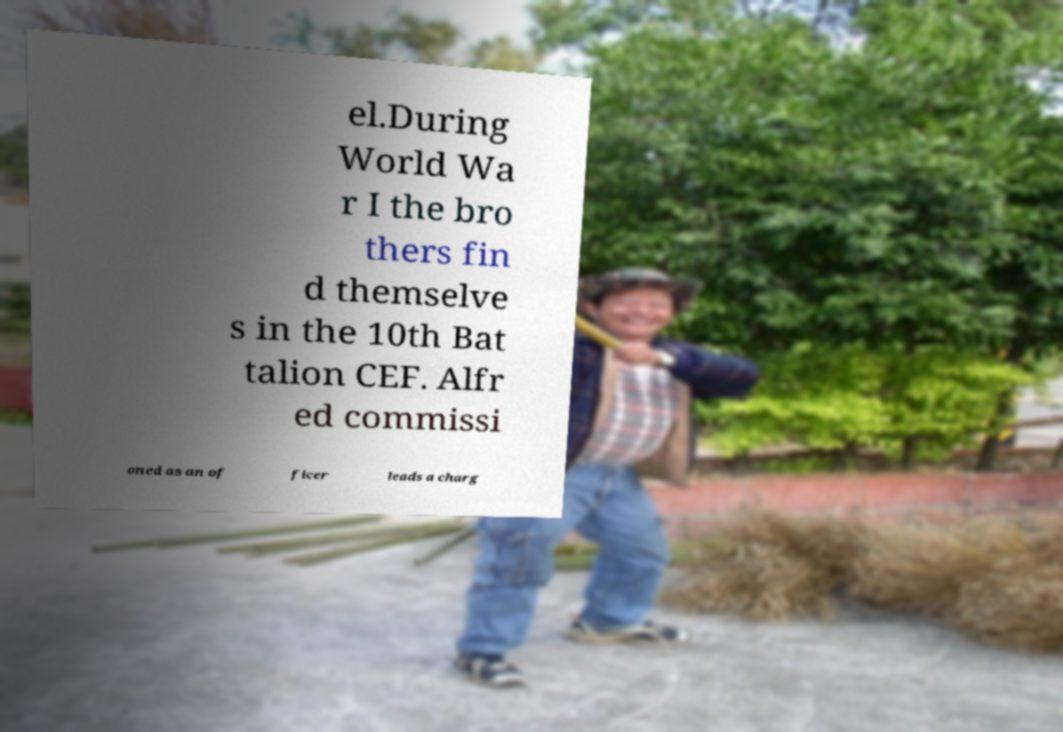There's text embedded in this image that I need extracted. Can you transcribe it verbatim? el.During World Wa r I the bro thers fin d themselve s in the 10th Bat talion CEF. Alfr ed commissi oned as an of ficer leads a charg 